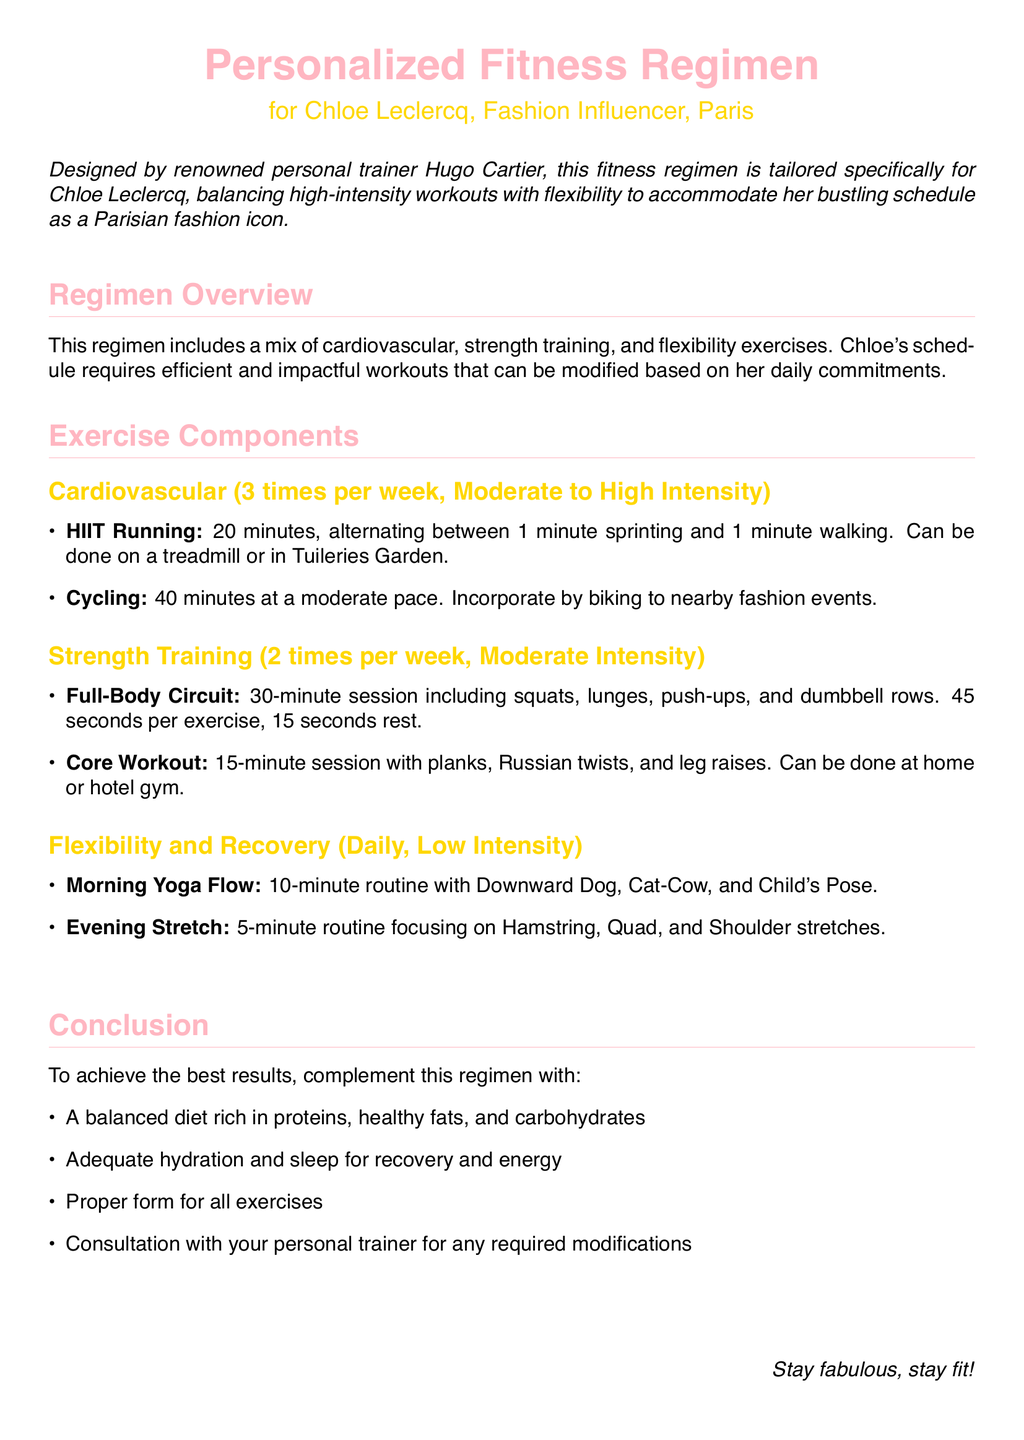What is the frequency of cardiovascular exercises? The document states that cardiovascular exercises are recommended 3 times per week.
Answer: 3 times per week What type of training is scheduled twice a week? The document mentions a specific training type that occurs two times weekly, which is strength training.
Answer: Strength training How long should the HIIT Running last? The document specifies that the HIIT Running session should last for 20 minutes.
Answer: 20 minutes What is one flexibility exercise to perform daily? The document lists yoga as a daily flexibility exercise, specifically naming the Morning Yoga Flow.
Answer: Morning Yoga Flow What intensity level is recommended for strength training? The document indicates that strength training should be performed at a moderate intensity level.
Answer: Moderate intensity Which exercises are included in the full-body circuit? The document details specific exercises that include squats, lunges, push-ups, and dumbbell rows.
Answer: Squats, lunges, push-ups, and dumbbell rows How many minutes is the core workout? The document states that the core workout is a 15-minute session.
Answer: 15 minutes What should be complemented with the workout regimen for best results? The document lists several recommendations, one being a balanced diet rich in proteins, healthy fats, and carbohydrates.
Answer: A balanced diet What color is used to define section titles? The document specifies that section titles are colored fashion pink.
Answer: Fashion pink 